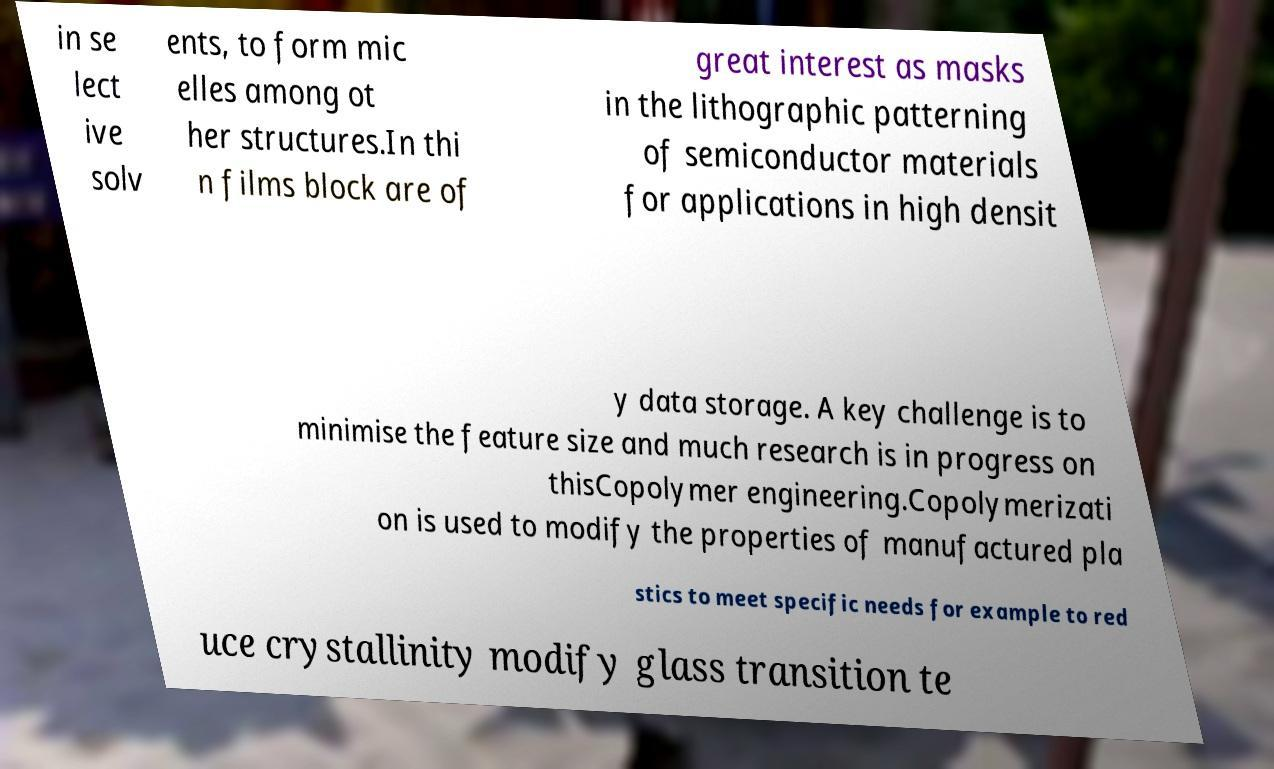Can you accurately transcribe the text from the provided image for me? in se lect ive solv ents, to form mic elles among ot her structures.In thi n films block are of great interest as masks in the lithographic patterning of semiconductor materials for applications in high densit y data storage. A key challenge is to minimise the feature size and much research is in progress on thisCopolymer engineering.Copolymerizati on is used to modify the properties of manufactured pla stics to meet specific needs for example to red uce crystallinity modify glass transition te 